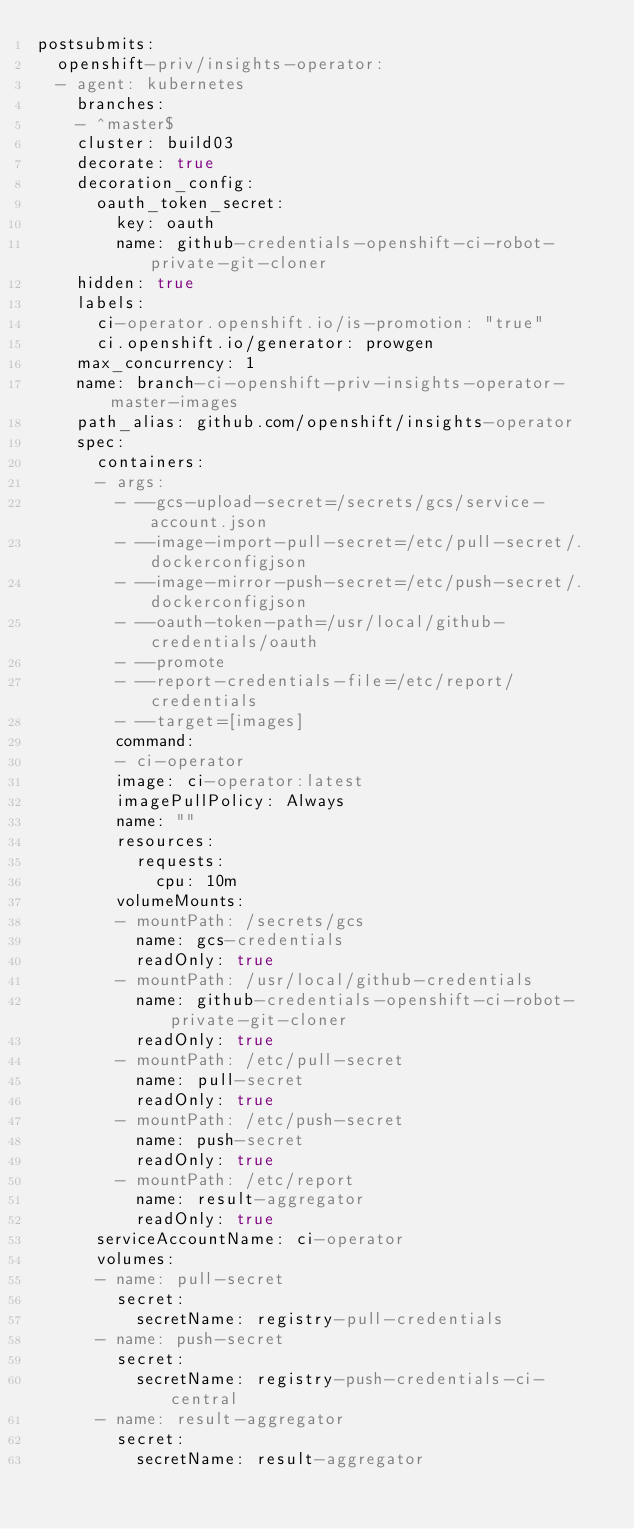<code> <loc_0><loc_0><loc_500><loc_500><_YAML_>postsubmits:
  openshift-priv/insights-operator:
  - agent: kubernetes
    branches:
    - ^master$
    cluster: build03
    decorate: true
    decoration_config:
      oauth_token_secret:
        key: oauth
        name: github-credentials-openshift-ci-robot-private-git-cloner
    hidden: true
    labels:
      ci-operator.openshift.io/is-promotion: "true"
      ci.openshift.io/generator: prowgen
    max_concurrency: 1
    name: branch-ci-openshift-priv-insights-operator-master-images
    path_alias: github.com/openshift/insights-operator
    spec:
      containers:
      - args:
        - --gcs-upload-secret=/secrets/gcs/service-account.json
        - --image-import-pull-secret=/etc/pull-secret/.dockerconfigjson
        - --image-mirror-push-secret=/etc/push-secret/.dockerconfigjson
        - --oauth-token-path=/usr/local/github-credentials/oauth
        - --promote
        - --report-credentials-file=/etc/report/credentials
        - --target=[images]
        command:
        - ci-operator
        image: ci-operator:latest
        imagePullPolicy: Always
        name: ""
        resources:
          requests:
            cpu: 10m
        volumeMounts:
        - mountPath: /secrets/gcs
          name: gcs-credentials
          readOnly: true
        - mountPath: /usr/local/github-credentials
          name: github-credentials-openshift-ci-robot-private-git-cloner
          readOnly: true
        - mountPath: /etc/pull-secret
          name: pull-secret
          readOnly: true
        - mountPath: /etc/push-secret
          name: push-secret
          readOnly: true
        - mountPath: /etc/report
          name: result-aggregator
          readOnly: true
      serviceAccountName: ci-operator
      volumes:
      - name: pull-secret
        secret:
          secretName: registry-pull-credentials
      - name: push-secret
        secret:
          secretName: registry-push-credentials-ci-central
      - name: result-aggregator
        secret:
          secretName: result-aggregator
</code> 